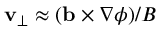<formula> <loc_0><loc_0><loc_500><loc_500>v _ { \perp } \approx ( b \times \nabla \phi ) / B</formula> 